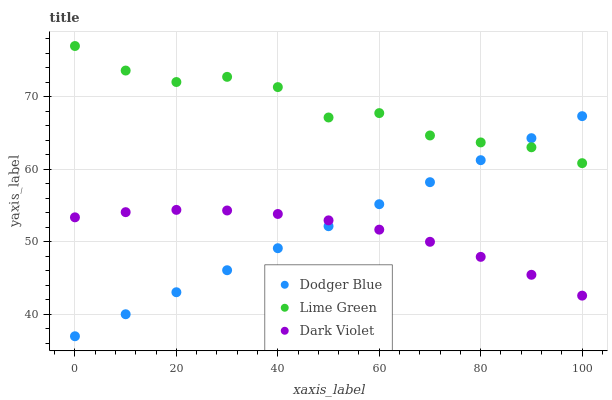Does Dark Violet have the minimum area under the curve?
Answer yes or no. Yes. Does Lime Green have the maximum area under the curve?
Answer yes or no. Yes. Does Dodger Blue have the minimum area under the curve?
Answer yes or no. No. Does Dodger Blue have the maximum area under the curve?
Answer yes or no. No. Is Dodger Blue the smoothest?
Answer yes or no. Yes. Is Lime Green the roughest?
Answer yes or no. Yes. Is Dark Violet the smoothest?
Answer yes or no. No. Is Dark Violet the roughest?
Answer yes or no. No. Does Dodger Blue have the lowest value?
Answer yes or no. Yes. Does Dark Violet have the lowest value?
Answer yes or no. No. Does Lime Green have the highest value?
Answer yes or no. Yes. Does Dodger Blue have the highest value?
Answer yes or no. No. Is Dark Violet less than Lime Green?
Answer yes or no. Yes. Is Lime Green greater than Dark Violet?
Answer yes or no. Yes. Does Dodger Blue intersect Dark Violet?
Answer yes or no. Yes. Is Dodger Blue less than Dark Violet?
Answer yes or no. No. Is Dodger Blue greater than Dark Violet?
Answer yes or no. No. Does Dark Violet intersect Lime Green?
Answer yes or no. No. 